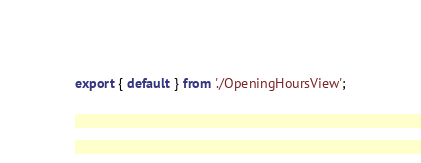Convert code to text. <code><loc_0><loc_0><loc_500><loc_500><_JavaScript_>export { default } from './OpeningHoursView';
</code> 